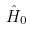<formula> <loc_0><loc_0><loc_500><loc_500>\hat { H } _ { 0 }</formula> 